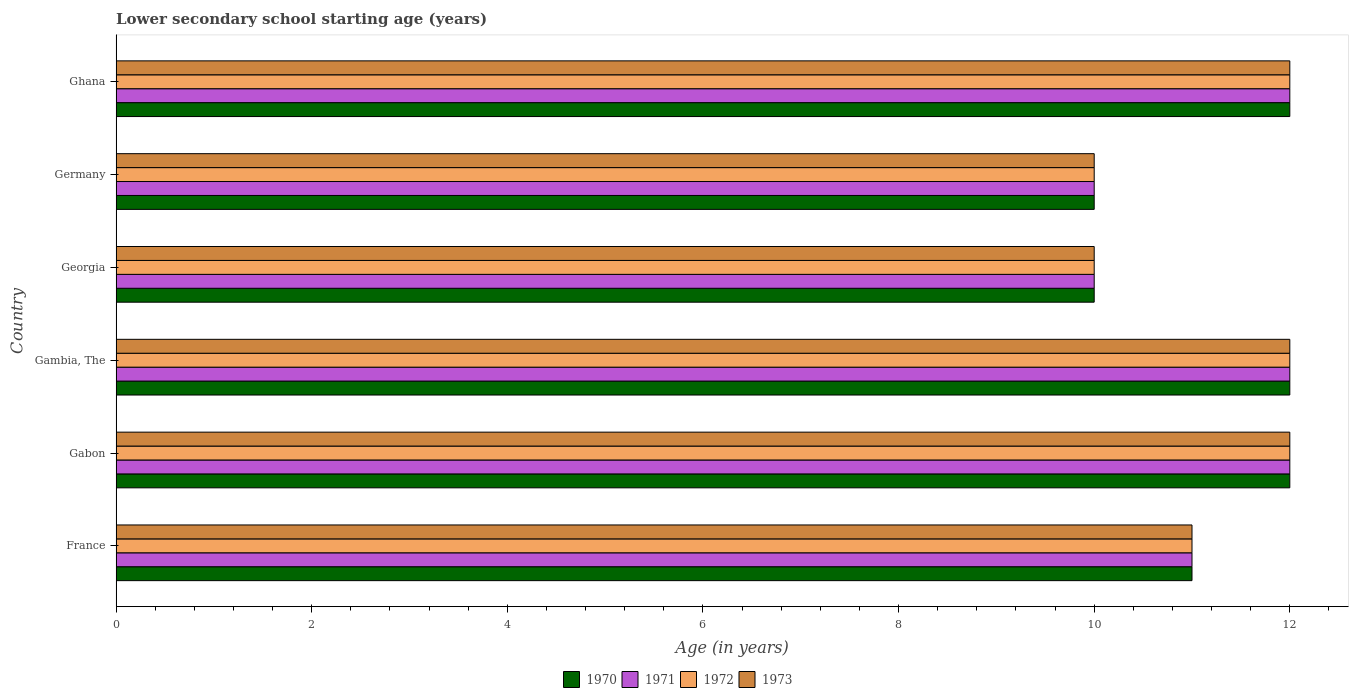How many different coloured bars are there?
Provide a succinct answer. 4. How many groups of bars are there?
Provide a short and direct response. 6. In how many cases, is the number of bars for a given country not equal to the number of legend labels?
Make the answer very short. 0. In which country was the lower secondary school starting age of children in 1970 maximum?
Offer a terse response. Gabon. In which country was the lower secondary school starting age of children in 1972 minimum?
Keep it short and to the point. Georgia. What is the total lower secondary school starting age of children in 1971 in the graph?
Make the answer very short. 67. What is the average lower secondary school starting age of children in 1973 per country?
Provide a succinct answer. 11.17. What is the ratio of the lower secondary school starting age of children in 1972 in Gambia, The to that in Ghana?
Your answer should be very brief. 1. Is the lower secondary school starting age of children in 1973 in France less than that in Ghana?
Offer a very short reply. Yes. In how many countries, is the lower secondary school starting age of children in 1971 greater than the average lower secondary school starting age of children in 1971 taken over all countries?
Provide a succinct answer. 3. Is it the case that in every country, the sum of the lower secondary school starting age of children in 1973 and lower secondary school starting age of children in 1970 is greater than the sum of lower secondary school starting age of children in 1972 and lower secondary school starting age of children in 1971?
Provide a succinct answer. No. What does the 3rd bar from the top in Ghana represents?
Ensure brevity in your answer.  1971. How many countries are there in the graph?
Your answer should be very brief. 6. Does the graph contain any zero values?
Make the answer very short. No. How many legend labels are there?
Your answer should be very brief. 4. What is the title of the graph?
Offer a terse response. Lower secondary school starting age (years). What is the label or title of the X-axis?
Give a very brief answer. Age (in years). What is the Age (in years) of 1970 in France?
Give a very brief answer. 11. What is the Age (in years) in 1972 in France?
Provide a succinct answer. 11. What is the Age (in years) in 1973 in France?
Offer a terse response. 11. What is the Age (in years) of 1970 in Gabon?
Provide a short and direct response. 12. What is the Age (in years) of 1971 in Gabon?
Keep it short and to the point. 12. What is the Age (in years) in 1972 in Gabon?
Provide a short and direct response. 12. What is the Age (in years) of 1971 in Gambia, The?
Ensure brevity in your answer.  12. What is the Age (in years) of 1972 in Gambia, The?
Ensure brevity in your answer.  12. What is the Age (in years) in 1970 in Georgia?
Keep it short and to the point. 10. What is the Age (in years) of 1973 in Georgia?
Provide a short and direct response. 10. What is the Age (in years) of 1971 in Germany?
Offer a terse response. 10. What is the Age (in years) in 1971 in Ghana?
Keep it short and to the point. 12. Across all countries, what is the maximum Age (in years) in 1970?
Make the answer very short. 12. Across all countries, what is the maximum Age (in years) of 1971?
Provide a succinct answer. 12. Across all countries, what is the maximum Age (in years) in 1972?
Keep it short and to the point. 12. Across all countries, what is the maximum Age (in years) in 1973?
Provide a short and direct response. 12. Across all countries, what is the minimum Age (in years) of 1973?
Keep it short and to the point. 10. What is the total Age (in years) in 1970 in the graph?
Give a very brief answer. 67. What is the total Age (in years) of 1971 in the graph?
Give a very brief answer. 67. What is the total Age (in years) in 1973 in the graph?
Provide a succinct answer. 67. What is the difference between the Age (in years) of 1971 in France and that in Gabon?
Give a very brief answer. -1. What is the difference between the Age (in years) in 1971 in France and that in Gambia, The?
Your response must be concise. -1. What is the difference between the Age (in years) in 1972 in France and that in Gambia, The?
Offer a very short reply. -1. What is the difference between the Age (in years) of 1973 in France and that in Gambia, The?
Ensure brevity in your answer.  -1. What is the difference between the Age (in years) in 1972 in France and that in Georgia?
Make the answer very short. 1. What is the difference between the Age (in years) of 1972 in France and that in Germany?
Your response must be concise. 1. What is the difference between the Age (in years) in 1971 in France and that in Ghana?
Ensure brevity in your answer.  -1. What is the difference between the Age (in years) in 1972 in France and that in Ghana?
Make the answer very short. -1. What is the difference between the Age (in years) of 1973 in France and that in Ghana?
Provide a short and direct response. -1. What is the difference between the Age (in years) in 1970 in Gabon and that in Gambia, The?
Offer a terse response. 0. What is the difference between the Age (in years) of 1972 in Gabon and that in Gambia, The?
Give a very brief answer. 0. What is the difference between the Age (in years) of 1972 in Gabon and that in Georgia?
Give a very brief answer. 2. What is the difference between the Age (in years) of 1971 in Gabon and that in Germany?
Make the answer very short. 2. What is the difference between the Age (in years) of 1972 in Gabon and that in Germany?
Provide a short and direct response. 2. What is the difference between the Age (in years) in 1970 in Gabon and that in Ghana?
Ensure brevity in your answer.  0. What is the difference between the Age (in years) in 1971 in Gabon and that in Ghana?
Give a very brief answer. 0. What is the difference between the Age (in years) of 1972 in Gabon and that in Ghana?
Make the answer very short. 0. What is the difference between the Age (in years) in 1973 in Gabon and that in Ghana?
Provide a short and direct response. 0. What is the difference between the Age (in years) of 1972 in Gambia, The and that in Georgia?
Offer a terse response. 2. What is the difference between the Age (in years) of 1973 in Gambia, The and that in Georgia?
Provide a short and direct response. 2. What is the difference between the Age (in years) of 1970 in Gambia, The and that in Germany?
Your answer should be very brief. 2. What is the difference between the Age (in years) in 1972 in Gambia, The and that in Germany?
Provide a succinct answer. 2. What is the difference between the Age (in years) in 1972 in Gambia, The and that in Ghana?
Give a very brief answer. 0. What is the difference between the Age (in years) in 1970 in Georgia and that in Germany?
Offer a very short reply. 0. What is the difference between the Age (in years) in 1973 in Georgia and that in Germany?
Give a very brief answer. 0. What is the difference between the Age (in years) of 1971 in Georgia and that in Ghana?
Your answer should be compact. -2. What is the difference between the Age (in years) in 1972 in Georgia and that in Ghana?
Make the answer very short. -2. What is the difference between the Age (in years) in 1973 in Georgia and that in Ghana?
Offer a very short reply. -2. What is the difference between the Age (in years) of 1970 in Germany and that in Ghana?
Make the answer very short. -2. What is the difference between the Age (in years) in 1971 in Germany and that in Ghana?
Provide a short and direct response. -2. What is the difference between the Age (in years) in 1973 in Germany and that in Ghana?
Provide a succinct answer. -2. What is the difference between the Age (in years) in 1970 in France and the Age (in years) in 1972 in Gabon?
Your answer should be compact. -1. What is the difference between the Age (in years) in 1971 in France and the Age (in years) in 1973 in Gabon?
Your answer should be compact. -1. What is the difference between the Age (in years) in 1971 in France and the Age (in years) in 1973 in Gambia, The?
Your answer should be very brief. -1. What is the difference between the Age (in years) of 1970 in France and the Age (in years) of 1972 in Georgia?
Give a very brief answer. 1. What is the difference between the Age (in years) of 1971 in France and the Age (in years) of 1972 in Georgia?
Ensure brevity in your answer.  1. What is the difference between the Age (in years) of 1971 in France and the Age (in years) of 1973 in Georgia?
Your answer should be compact. 1. What is the difference between the Age (in years) of 1970 in France and the Age (in years) of 1971 in Germany?
Make the answer very short. 1. What is the difference between the Age (in years) of 1971 in France and the Age (in years) of 1973 in Germany?
Your response must be concise. 1. What is the difference between the Age (in years) in 1972 in France and the Age (in years) in 1973 in Germany?
Offer a very short reply. 1. What is the difference between the Age (in years) of 1970 in France and the Age (in years) of 1971 in Ghana?
Provide a short and direct response. -1. What is the difference between the Age (in years) in 1970 in France and the Age (in years) in 1972 in Ghana?
Ensure brevity in your answer.  -1. What is the difference between the Age (in years) in 1970 in France and the Age (in years) in 1973 in Ghana?
Keep it short and to the point. -1. What is the difference between the Age (in years) in 1972 in France and the Age (in years) in 1973 in Ghana?
Make the answer very short. -1. What is the difference between the Age (in years) in 1970 in Gabon and the Age (in years) in 1971 in Gambia, The?
Give a very brief answer. 0. What is the difference between the Age (in years) of 1970 in Gabon and the Age (in years) of 1972 in Gambia, The?
Offer a very short reply. 0. What is the difference between the Age (in years) of 1971 in Gabon and the Age (in years) of 1972 in Gambia, The?
Offer a very short reply. 0. What is the difference between the Age (in years) of 1971 in Gabon and the Age (in years) of 1973 in Gambia, The?
Offer a terse response. 0. What is the difference between the Age (in years) of 1970 in Gabon and the Age (in years) of 1971 in Georgia?
Offer a terse response. 2. What is the difference between the Age (in years) of 1970 in Gabon and the Age (in years) of 1972 in Georgia?
Your answer should be very brief. 2. What is the difference between the Age (in years) of 1971 in Gabon and the Age (in years) of 1972 in Georgia?
Your response must be concise. 2. What is the difference between the Age (in years) of 1970 in Gabon and the Age (in years) of 1971 in Germany?
Give a very brief answer. 2. What is the difference between the Age (in years) in 1970 in Gabon and the Age (in years) in 1972 in Germany?
Ensure brevity in your answer.  2. What is the difference between the Age (in years) of 1970 in Gabon and the Age (in years) of 1973 in Germany?
Your answer should be very brief. 2. What is the difference between the Age (in years) in 1971 in Gabon and the Age (in years) in 1972 in Germany?
Your answer should be very brief. 2. What is the difference between the Age (in years) in 1972 in Gabon and the Age (in years) in 1973 in Germany?
Your response must be concise. 2. What is the difference between the Age (in years) of 1970 in Gabon and the Age (in years) of 1971 in Ghana?
Give a very brief answer. 0. What is the difference between the Age (in years) in 1970 in Gabon and the Age (in years) in 1972 in Ghana?
Offer a terse response. 0. What is the difference between the Age (in years) of 1970 in Gabon and the Age (in years) of 1973 in Ghana?
Your answer should be very brief. 0. What is the difference between the Age (in years) in 1971 in Gabon and the Age (in years) in 1972 in Ghana?
Offer a very short reply. 0. What is the difference between the Age (in years) in 1971 in Gabon and the Age (in years) in 1973 in Ghana?
Offer a very short reply. 0. What is the difference between the Age (in years) of 1970 in Gambia, The and the Age (in years) of 1972 in Georgia?
Provide a short and direct response. 2. What is the difference between the Age (in years) in 1971 in Gambia, The and the Age (in years) in 1973 in Georgia?
Give a very brief answer. 2. What is the difference between the Age (in years) of 1972 in Gambia, The and the Age (in years) of 1973 in Georgia?
Your answer should be compact. 2. What is the difference between the Age (in years) in 1970 in Gambia, The and the Age (in years) in 1971 in Germany?
Provide a succinct answer. 2. What is the difference between the Age (in years) in 1970 in Gambia, The and the Age (in years) in 1972 in Germany?
Provide a succinct answer. 2. What is the difference between the Age (in years) in 1970 in Gambia, The and the Age (in years) in 1973 in Germany?
Your answer should be compact. 2. What is the difference between the Age (in years) in 1971 in Gambia, The and the Age (in years) in 1972 in Germany?
Give a very brief answer. 2. What is the difference between the Age (in years) in 1971 in Gambia, The and the Age (in years) in 1973 in Germany?
Offer a very short reply. 2. What is the difference between the Age (in years) in 1970 in Gambia, The and the Age (in years) in 1971 in Ghana?
Your answer should be very brief. 0. What is the difference between the Age (in years) in 1970 in Georgia and the Age (in years) in 1971 in Germany?
Make the answer very short. 0. What is the difference between the Age (in years) of 1970 in Georgia and the Age (in years) of 1972 in Germany?
Your answer should be very brief. 0. What is the difference between the Age (in years) in 1971 in Georgia and the Age (in years) in 1972 in Germany?
Keep it short and to the point. 0. What is the difference between the Age (in years) of 1971 in Georgia and the Age (in years) of 1973 in Germany?
Offer a terse response. 0. What is the difference between the Age (in years) in 1970 in Georgia and the Age (in years) in 1972 in Ghana?
Provide a succinct answer. -2. What is the difference between the Age (in years) in 1972 in Georgia and the Age (in years) in 1973 in Ghana?
Provide a succinct answer. -2. What is the difference between the Age (in years) of 1971 in Germany and the Age (in years) of 1972 in Ghana?
Offer a very short reply. -2. What is the difference between the Age (in years) in 1971 in Germany and the Age (in years) in 1973 in Ghana?
Your answer should be compact. -2. What is the average Age (in years) of 1970 per country?
Keep it short and to the point. 11.17. What is the average Age (in years) of 1971 per country?
Ensure brevity in your answer.  11.17. What is the average Age (in years) of 1972 per country?
Offer a very short reply. 11.17. What is the average Age (in years) of 1973 per country?
Your answer should be very brief. 11.17. What is the difference between the Age (in years) in 1970 and Age (in years) in 1971 in France?
Make the answer very short. 0. What is the difference between the Age (in years) of 1970 and Age (in years) of 1972 in France?
Provide a succinct answer. 0. What is the difference between the Age (in years) of 1970 and Age (in years) of 1971 in Gabon?
Make the answer very short. 0. What is the difference between the Age (in years) in 1970 and Age (in years) in 1973 in Gabon?
Offer a terse response. 0. What is the difference between the Age (in years) of 1972 and Age (in years) of 1973 in Gabon?
Keep it short and to the point. 0. What is the difference between the Age (in years) in 1970 and Age (in years) in 1971 in Gambia, The?
Keep it short and to the point. 0. What is the difference between the Age (in years) of 1970 and Age (in years) of 1973 in Gambia, The?
Make the answer very short. 0. What is the difference between the Age (in years) of 1971 and Age (in years) of 1973 in Gambia, The?
Offer a terse response. 0. What is the difference between the Age (in years) in 1972 and Age (in years) in 1973 in Gambia, The?
Your answer should be very brief. 0. What is the difference between the Age (in years) of 1971 and Age (in years) of 1972 in Georgia?
Your answer should be very brief. 0. What is the difference between the Age (in years) of 1971 and Age (in years) of 1972 in Germany?
Offer a very short reply. 0. What is the difference between the Age (in years) in 1971 and Age (in years) in 1973 in Germany?
Your answer should be very brief. 0. What is the difference between the Age (in years) in 1970 and Age (in years) in 1972 in Ghana?
Provide a succinct answer. 0. What is the difference between the Age (in years) of 1970 and Age (in years) of 1973 in Ghana?
Ensure brevity in your answer.  0. What is the difference between the Age (in years) of 1971 and Age (in years) of 1972 in Ghana?
Your answer should be compact. 0. What is the difference between the Age (in years) of 1972 and Age (in years) of 1973 in Ghana?
Make the answer very short. 0. What is the ratio of the Age (in years) in 1970 in France to that in Gabon?
Your answer should be compact. 0.92. What is the ratio of the Age (in years) of 1971 in France to that in Gabon?
Offer a very short reply. 0.92. What is the ratio of the Age (in years) of 1972 in France to that in Gabon?
Give a very brief answer. 0.92. What is the ratio of the Age (in years) in 1970 in France to that in Gambia, The?
Provide a succinct answer. 0.92. What is the ratio of the Age (in years) of 1973 in France to that in Gambia, The?
Offer a terse response. 0.92. What is the ratio of the Age (in years) of 1970 in France to that in Georgia?
Offer a terse response. 1.1. What is the ratio of the Age (in years) in 1973 in France to that in Georgia?
Your answer should be very brief. 1.1. What is the ratio of the Age (in years) in 1970 in France to that in Germany?
Keep it short and to the point. 1.1. What is the ratio of the Age (in years) of 1973 in France to that in Ghana?
Ensure brevity in your answer.  0.92. What is the ratio of the Age (in years) of 1970 in Gabon to that in Gambia, The?
Provide a succinct answer. 1. What is the ratio of the Age (in years) of 1971 in Gabon to that in Gambia, The?
Offer a very short reply. 1. What is the ratio of the Age (in years) of 1973 in Gabon to that in Georgia?
Ensure brevity in your answer.  1.2. What is the ratio of the Age (in years) of 1971 in Gambia, The to that in Georgia?
Offer a very short reply. 1.2. What is the ratio of the Age (in years) of 1972 in Gambia, The to that in Georgia?
Provide a short and direct response. 1.2. What is the ratio of the Age (in years) in 1973 in Gambia, The to that in Georgia?
Offer a terse response. 1.2. What is the ratio of the Age (in years) of 1971 in Gambia, The to that in Germany?
Your response must be concise. 1.2. What is the ratio of the Age (in years) in 1973 in Gambia, The to that in Germany?
Give a very brief answer. 1.2. What is the ratio of the Age (in years) of 1972 in Georgia to that in Germany?
Keep it short and to the point. 1. What is the ratio of the Age (in years) of 1973 in Georgia to that in Germany?
Offer a terse response. 1. What is the ratio of the Age (in years) of 1972 in Georgia to that in Ghana?
Offer a very short reply. 0.83. What is the difference between the highest and the second highest Age (in years) in 1971?
Your response must be concise. 0. What is the difference between the highest and the second highest Age (in years) in 1972?
Your answer should be compact. 0. What is the difference between the highest and the second highest Age (in years) of 1973?
Your response must be concise. 0. What is the difference between the highest and the lowest Age (in years) of 1971?
Make the answer very short. 2. What is the difference between the highest and the lowest Age (in years) of 1972?
Provide a short and direct response. 2. 